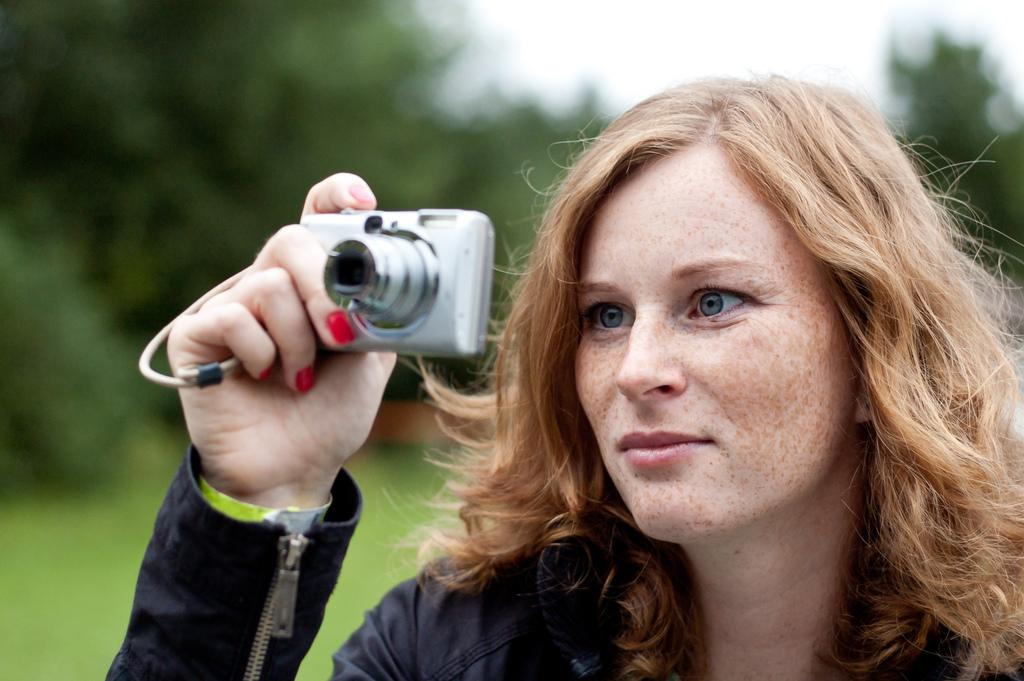Who is the main subject in the image? There is a woman in the image. What is the woman holding in her hand? The woman is holding a camera in her hand. What can be seen in the background of the image? There are trees in the background of the image. What type of clouds can be seen in the image? There are no clouds visible in the image; it only features a woman holding a camera with trees in the background. 